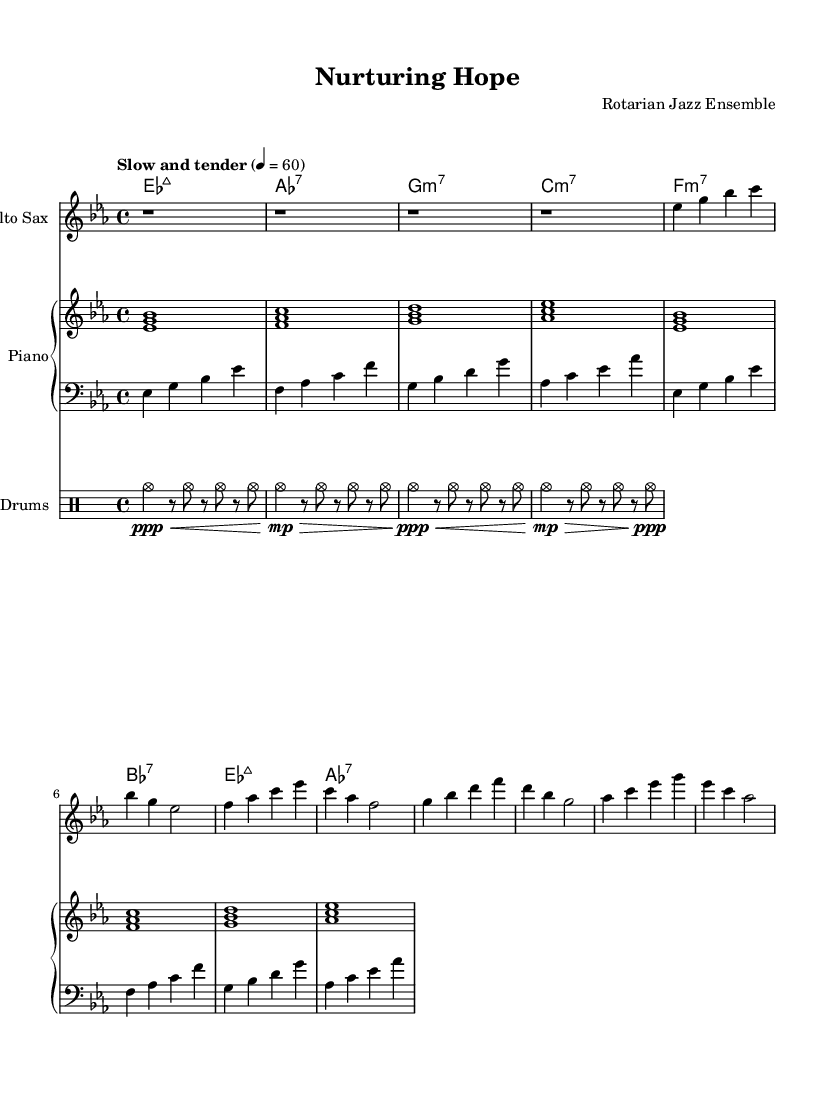What is the key signature of this music? The key signature indicated at the beginning of the sheet music shows two flats, which signifies the key of E-flat major.
Answer: E-flat major What is the time signature of this music? The time signature is located at the beginning of the score, shown as a 4 over 4 notation, indicating four beats in a measure.
Answer: 4/4 What is the tempo marking for this piece? The tempo is marked at the beginning with "Slow and tender," and the metronome marking is set to 60 beats per minute, indicating a slow pace.
Answer: Slow and tender, 60 How many measures are there in the saxophone part? Counting the measures in the saxophone line, there are a total of 8 measures in this part of the composition.
Answer: 8 measures What is the first chord in the piano part? The chord played in the first measure of the piano part is an E-flat major seventh chord, represented by the notes E-flat, G, and B-flat together.
Answer: E-flat major seventh Which instrument plays the melody in this piece? The melody is primarily played by the alto saxophone, as indicated by the staff labeled with "Alto Sax" at the beginning of that part.
Answer: Alto Sax What type of jazz is this piece categorized as? The title "Nurturing Hope" and the smooth, slow style of the composition suggest that it is a smooth jazz ballad, characterized by its emotional and lyrical melodies.
Answer: Smooth jazz ballad 